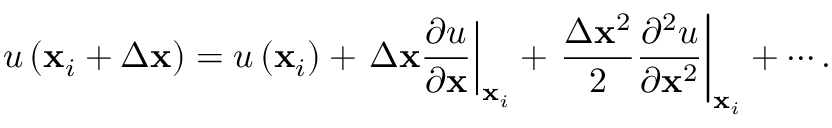Convert formula to latex. <formula><loc_0><loc_0><loc_500><loc_500>u \left ( x _ { i } + \Delta x \right ) = u \left ( x _ { i } \right ) + \Delta x \frac { \partial u } { \partial x } \right | _ { x _ { i } } + \frac { \Delta x ^ { 2 } } { 2 } \frac { \partial ^ { 2 } u } { \partial x ^ { 2 } } \right | _ { x _ { i } } + \cdots .</formula> 